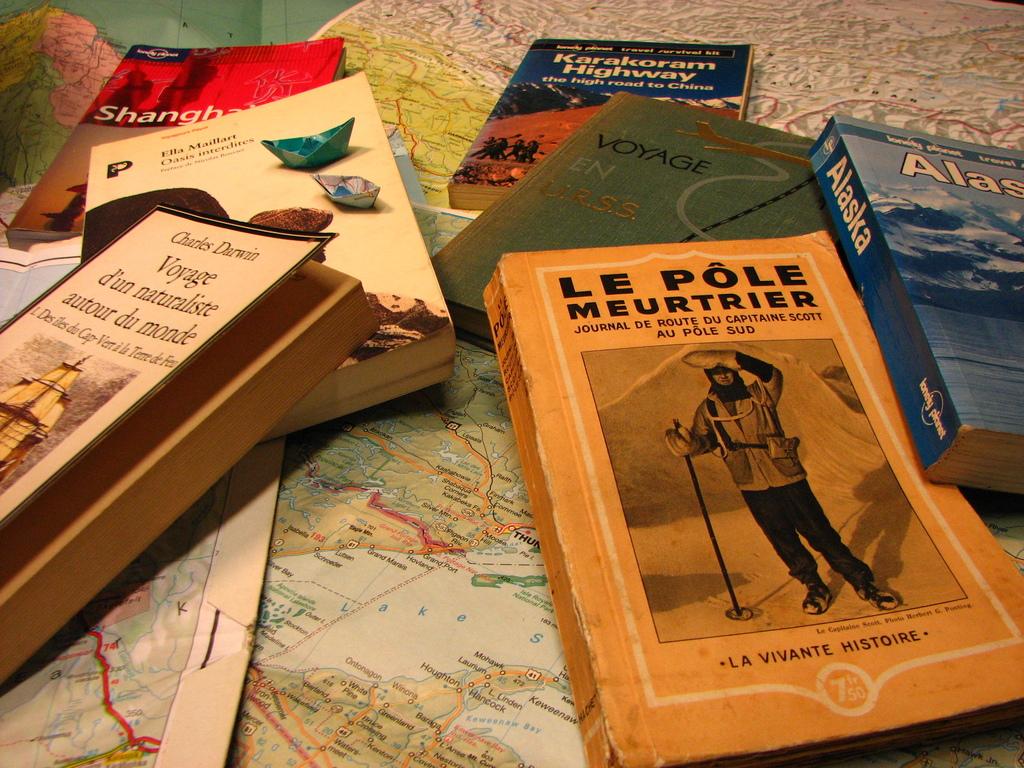What is the title of the book by lonely planet?
Offer a very short reply. Alaska. 